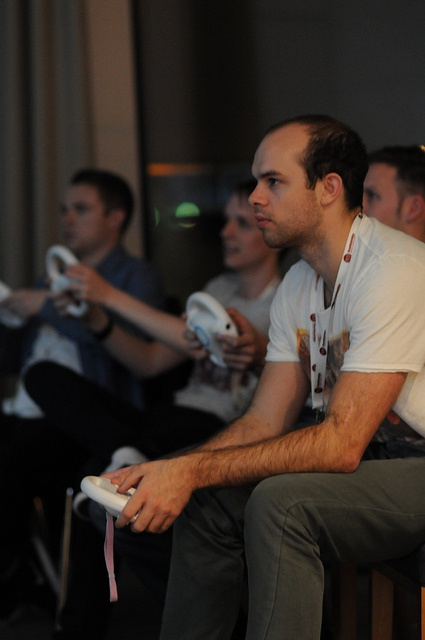Describe the objects in this image and their specific colors. I can see people in black, brown, and darkgray tones, people in black, gray, maroon, and brown tones, people in black, maroon, and gray tones, people in black, maroon, and brown tones, and chair in black tones in this image. 